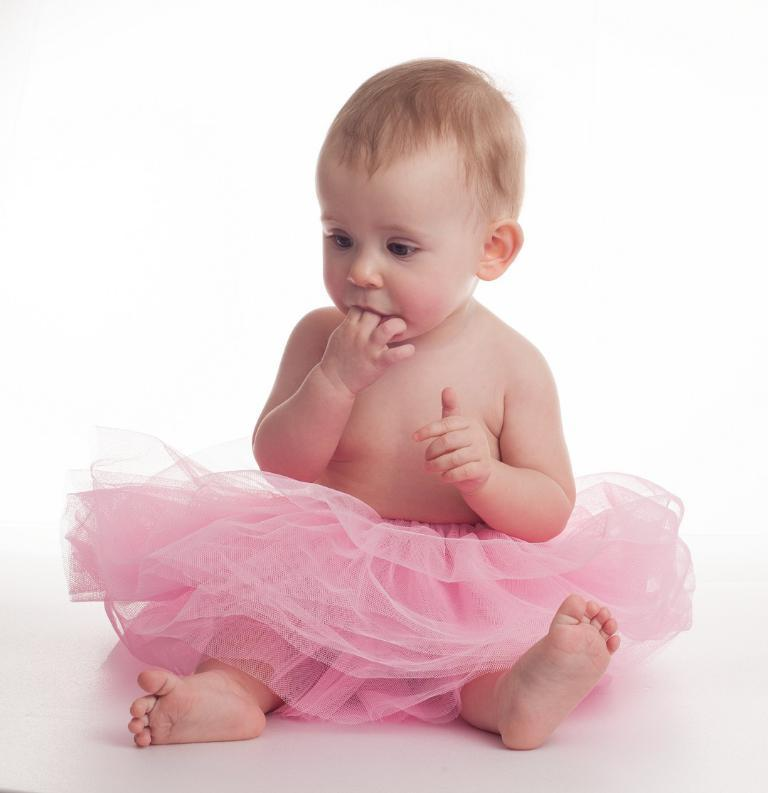What is the main subject of the image? There is a baby sitting in the image. What is the baby wearing? The baby is wearing a skirt. What color is the skirt? The skirt is light pink in color. What can be seen in the background of the image? The background of the image appears to be white. Is the baby attending a meeting in the image? There is no indication of a meeting in the image; it simply shows a baby sitting while wearing a light pink skirt. 